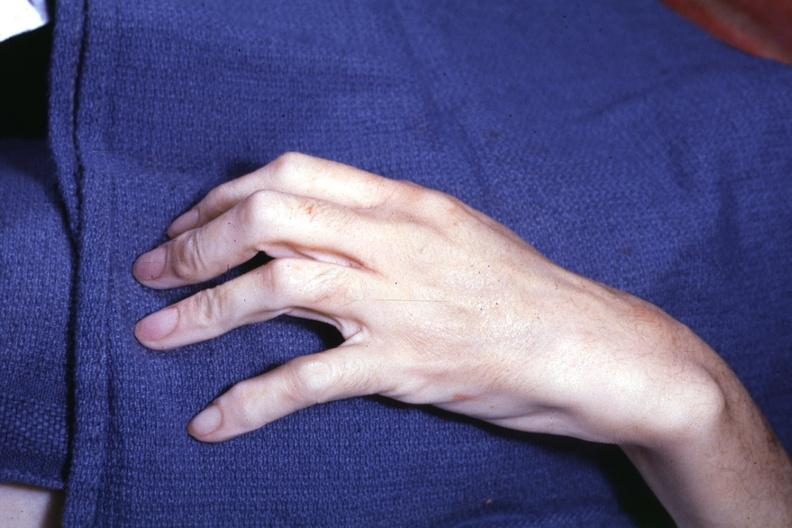what see other slides?
Answer the question using a single word or phrase. Long fingers interesting case 